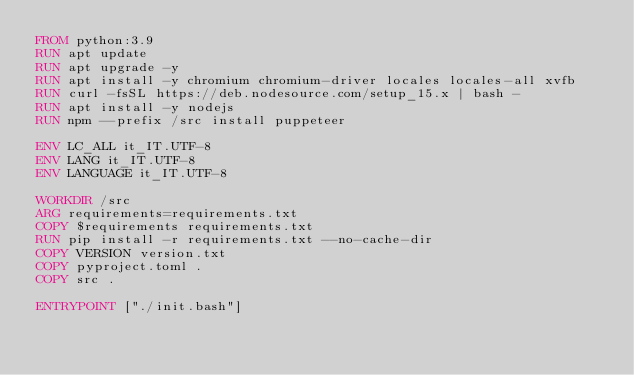<code> <loc_0><loc_0><loc_500><loc_500><_Dockerfile_>FROM python:3.9
RUN apt update
RUN apt upgrade -y
RUN apt install -y chromium chromium-driver locales locales-all xvfb
RUN curl -fsSL https://deb.nodesource.com/setup_15.x | bash -
RUN apt install -y nodejs
RUN npm --prefix /src install puppeteer

ENV LC_ALL it_IT.UTF-8
ENV LANG it_IT.UTF-8
ENV LANGUAGE it_IT.UTF-8

WORKDIR /src
ARG requirements=requirements.txt
COPY $requirements requirements.txt
RUN pip install -r requirements.txt --no-cache-dir
COPY VERSION version.txt
COPY pyproject.toml .
COPY src .

ENTRYPOINT ["./init.bash"]
</code> 